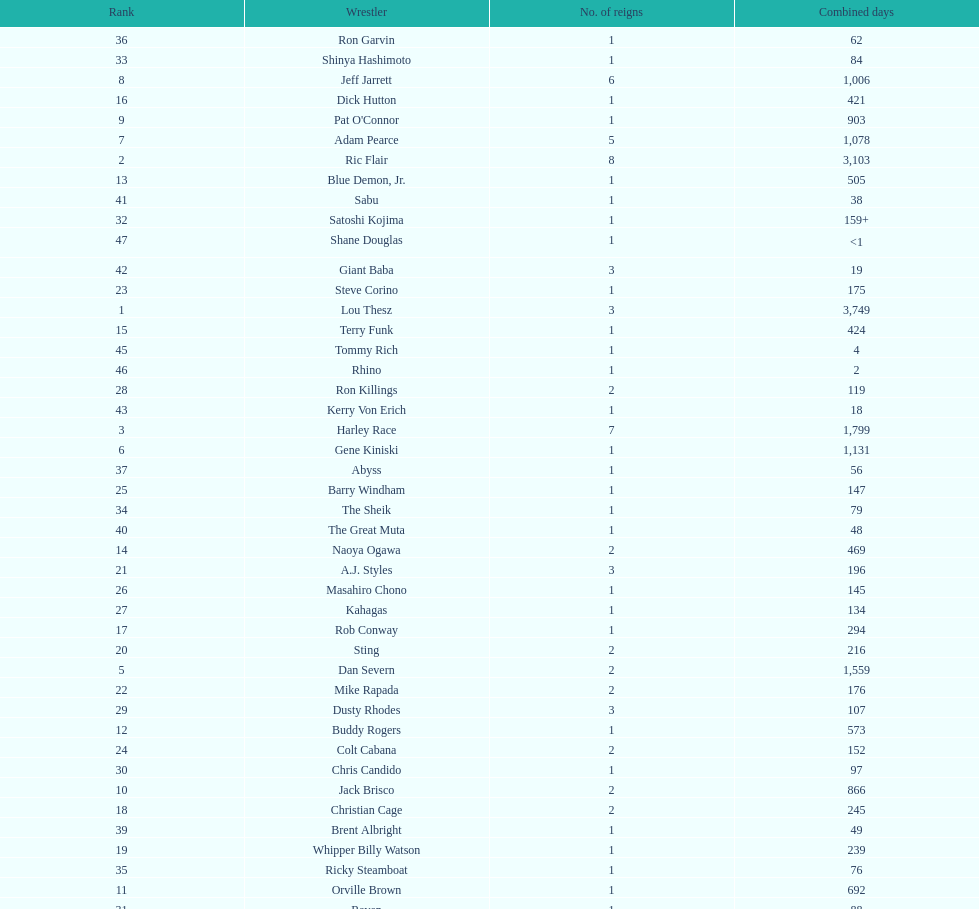Who has spent more time as nwa world heavyyweight champion, gene kiniski or ric flair? Ric Flair. Could you help me parse every detail presented in this table? {'header': ['Rank', 'Wrestler', 'No. of reigns', 'Combined days'], 'rows': [['36', 'Ron Garvin', '1', '62'], ['33', 'Shinya Hashimoto', '1', '84'], ['8', 'Jeff Jarrett', '6', '1,006'], ['16', 'Dick Hutton', '1', '421'], ['9', "Pat O'Connor", '1', '903'], ['7', 'Adam Pearce', '5', '1,078'], ['2', 'Ric Flair', '8', '3,103'], ['13', 'Blue Demon, Jr.', '1', '505'], ['41', 'Sabu', '1', '38'], ['32', 'Satoshi Kojima', '1', '159+'], ['47', 'Shane Douglas', '1', '<1'], ['42', 'Giant Baba', '3', '19'], ['23', 'Steve Corino', '1', '175'], ['1', 'Lou Thesz', '3', '3,749'], ['15', 'Terry Funk', '1', '424'], ['45', 'Tommy Rich', '1', '4'], ['46', 'Rhino', '1', '2'], ['28', 'Ron Killings', '2', '119'], ['43', 'Kerry Von Erich', '1', '18'], ['3', 'Harley Race', '7', '1,799'], ['6', 'Gene Kiniski', '1', '1,131'], ['37', 'Abyss', '1', '56'], ['25', 'Barry Windham', '1', '147'], ['34', 'The Sheik', '1', '79'], ['40', 'The Great Muta', '1', '48'], ['14', 'Naoya Ogawa', '2', '469'], ['21', 'A.J. Styles', '3', '196'], ['26', 'Masahiro Chono', '1', '145'], ['27', 'Kahagas', '1', '134'], ['17', 'Rob Conway', '1', '294'], ['20', 'Sting', '2', '216'], ['5', 'Dan Severn', '2', '1,559'], ['22', 'Mike Rapada', '2', '176'], ['29', 'Dusty Rhodes', '3', '107'], ['12', 'Buddy Rogers', '1', '573'], ['24', 'Colt Cabana', '2', '152'], ['30', 'Chris Candido', '1', '97'], ['10', 'Jack Brisco', '2', '866'], ['18', 'Christian Cage', '2', '245'], ['39', 'Brent Albright', '1', '49'], ['19', 'Whipper Billy Watson', '1', '239'], ['35', 'Ricky Steamboat', '1', '76'], ['11', 'Orville Brown', '1', '692'], ['31', 'Raven', '1', '88'], ['4', 'Dory Funk, Jr.', '1', '1,563'], ['44', 'Gary Steele', '1', '7'], ['39', 'Ken Shamrock', '1', '49']]} 